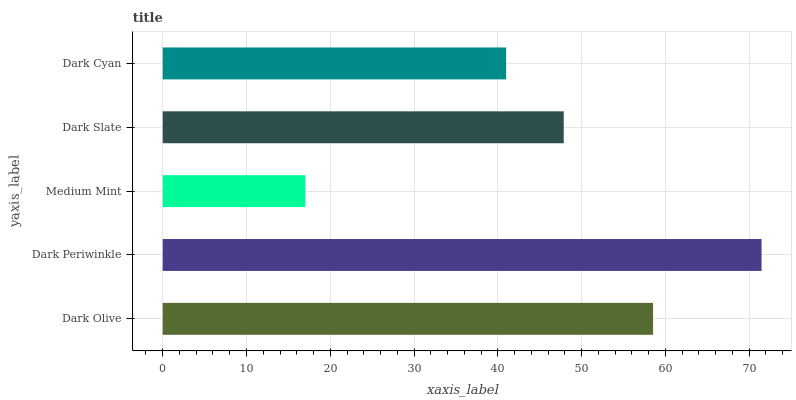Is Medium Mint the minimum?
Answer yes or no. Yes. Is Dark Periwinkle the maximum?
Answer yes or no. Yes. Is Dark Periwinkle the minimum?
Answer yes or no. No. Is Medium Mint the maximum?
Answer yes or no. No. Is Dark Periwinkle greater than Medium Mint?
Answer yes or no. Yes. Is Medium Mint less than Dark Periwinkle?
Answer yes or no. Yes. Is Medium Mint greater than Dark Periwinkle?
Answer yes or no. No. Is Dark Periwinkle less than Medium Mint?
Answer yes or no. No. Is Dark Slate the high median?
Answer yes or no. Yes. Is Dark Slate the low median?
Answer yes or no. Yes. Is Dark Periwinkle the high median?
Answer yes or no. No. Is Dark Olive the low median?
Answer yes or no. No. 